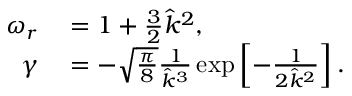Convert formula to latex. <formula><loc_0><loc_0><loc_500><loc_500>\begin{array} { r l } { \omega _ { r } } & = 1 + \frac { 3 } { 2 } \hat { k } ^ { 2 } , } \\ { \gamma } & = - \sqrt { \frac { \pi } { 8 } } \frac { 1 } { \hat { k } ^ { 3 } } \exp \left [ - \frac { 1 } { 2 \hat { k } ^ { 2 } } \right ] . } \end{array}</formula> 